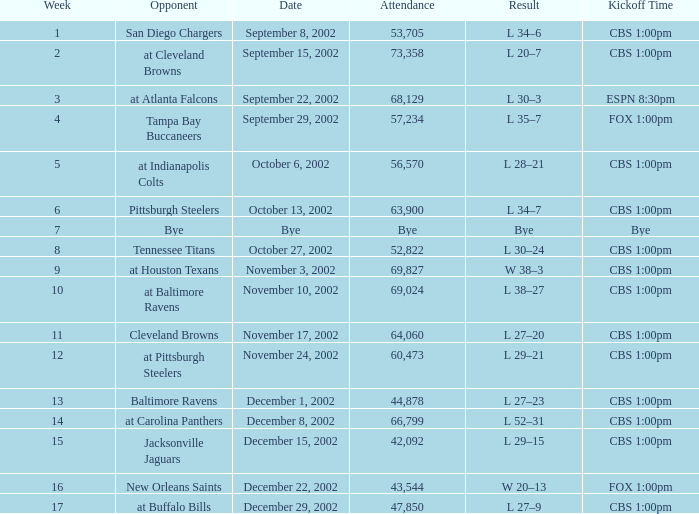What week number was the kickoff time cbs 1:00pm, with 60,473 people in attendance? 1.0. 